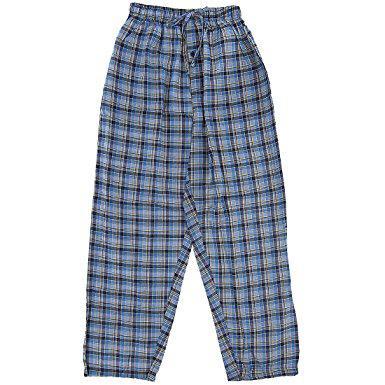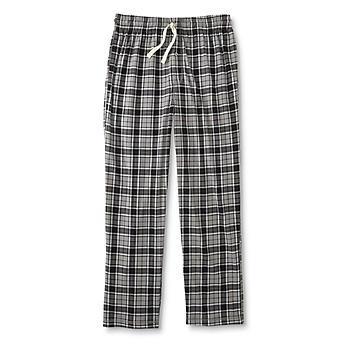The first image is the image on the left, the second image is the image on the right. Considering the images on both sides, is "All men's pajama pants have an elastic waist and a drawstring at the center front." valid? Answer yes or no. Yes. 